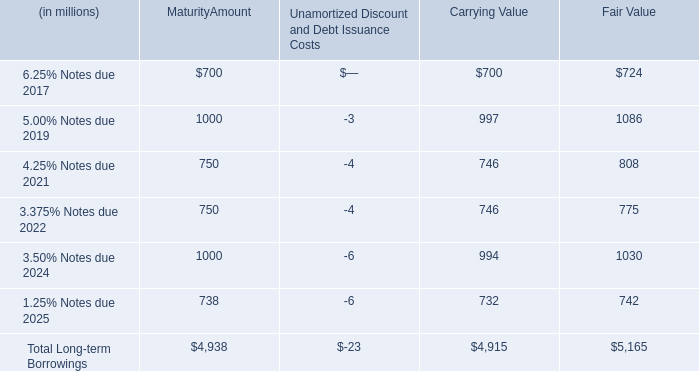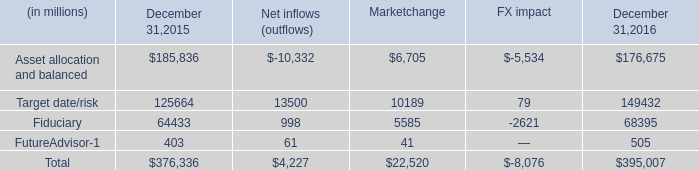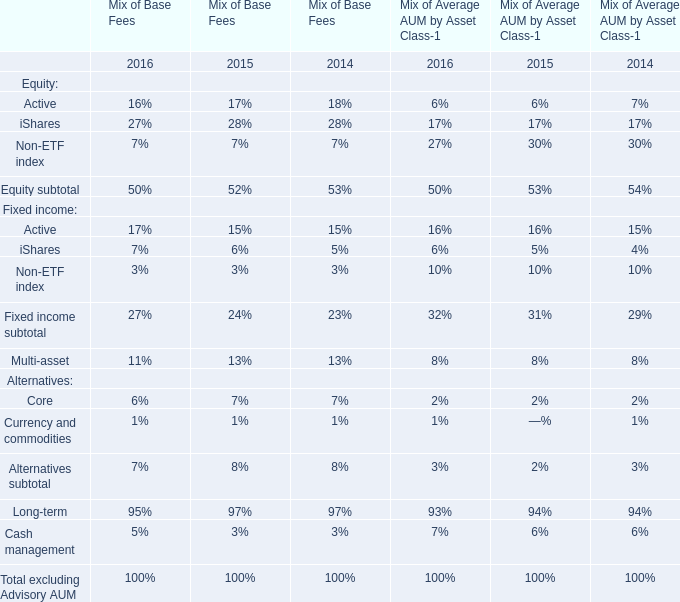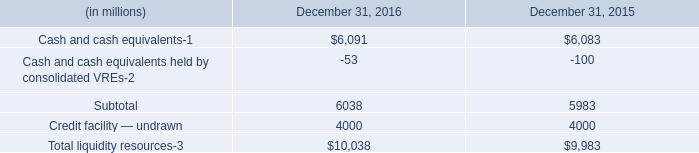what are the notes due 2021 as a percentage of total long-term borrowings? 
Computations: (750 / 4938)
Answer: 0.15188. 